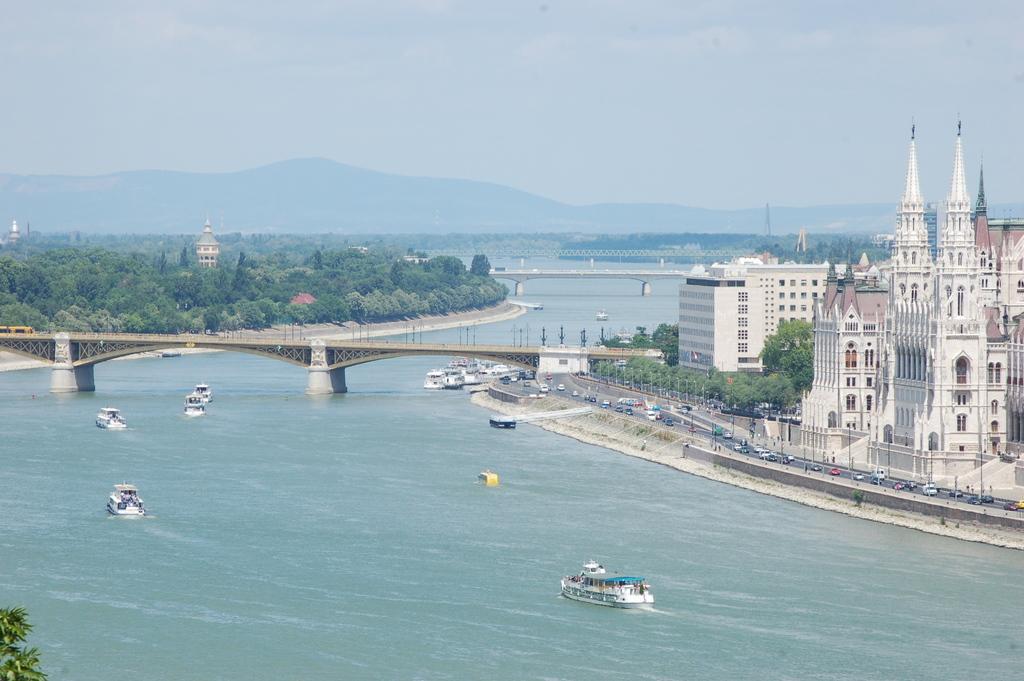How would you summarize this image in a sentence or two? There are few boats on water and there is a bridge above it and there are few buildings and vehicles in the right corner and there are trees and mountains in the background. 